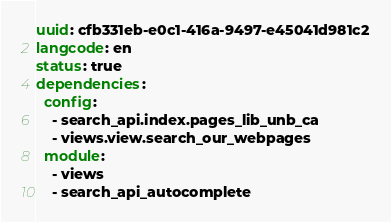<code> <loc_0><loc_0><loc_500><loc_500><_YAML_>uuid: cfb331eb-e0c1-416a-9497-e45041d981c2
langcode: en
status: true
dependencies:
  config:
    - search_api.index.pages_lib_unb_ca
    - views.view.search_our_webpages
  module:
    - views
    - search_api_autocomplete</code> 